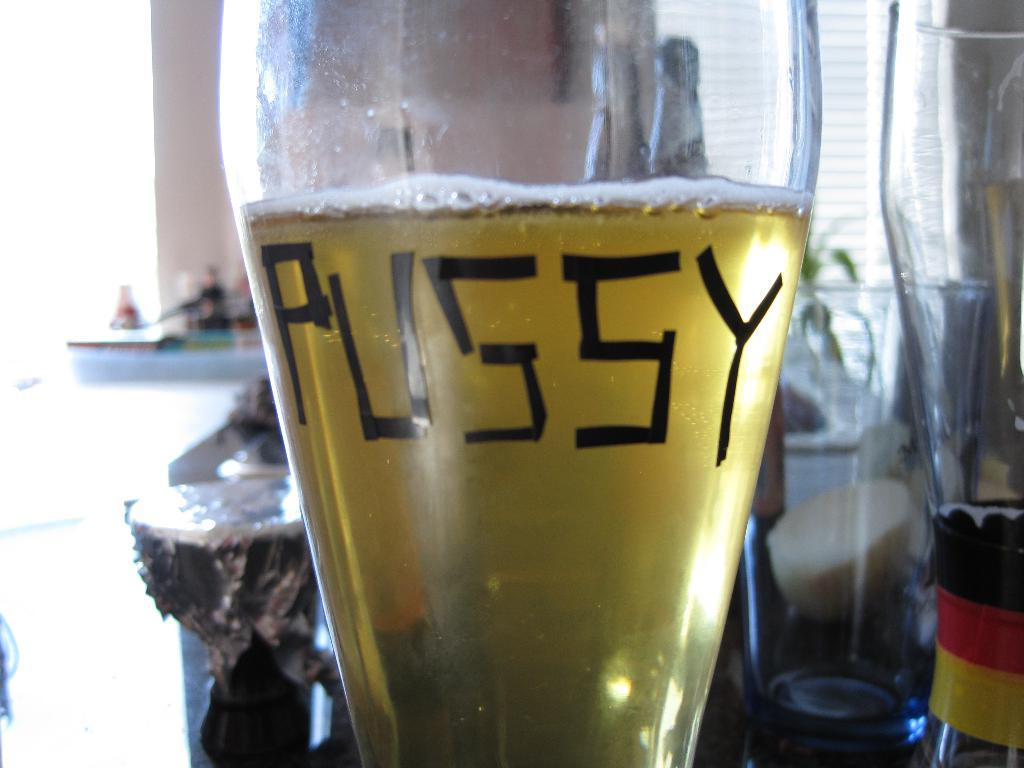Provide a one-sentence caption for the provided image. a close up of a glass of beer with the word Pussy written on it. 